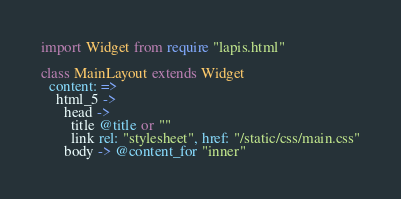Convert code to text. <code><loc_0><loc_0><loc_500><loc_500><_MoonScript_>import Widget from require "lapis.html"

class MainLayout extends Widget
  content: =>
    html_5 ->
      head ->
        title @title or ""
        link rel: "stylesheet", href: "/static/css/main.css"
      body -> @content_for "inner"
</code> 